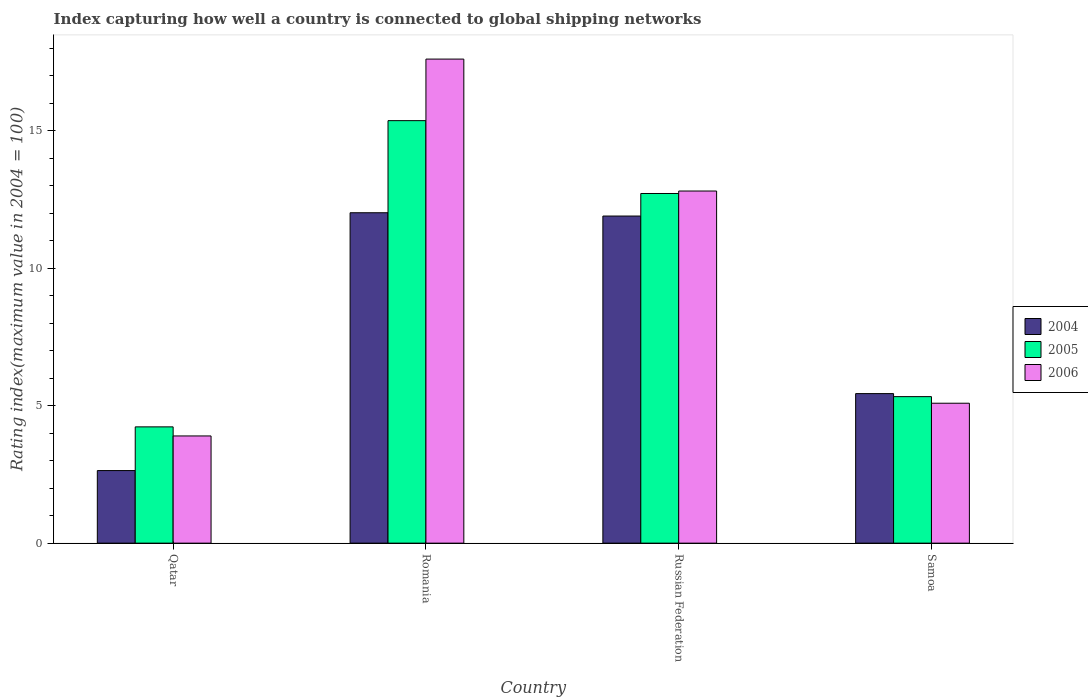How many groups of bars are there?
Your response must be concise. 4. Are the number of bars per tick equal to the number of legend labels?
Ensure brevity in your answer.  Yes. Are the number of bars on each tick of the X-axis equal?
Your answer should be compact. Yes. How many bars are there on the 2nd tick from the right?
Make the answer very short. 3. What is the label of the 2nd group of bars from the left?
Keep it short and to the point. Romania. In how many cases, is the number of bars for a given country not equal to the number of legend labels?
Provide a short and direct response. 0. What is the rating index in 2006 in Qatar?
Provide a succinct answer. 3.9. Across all countries, what is the maximum rating index in 2004?
Ensure brevity in your answer.  12.02. Across all countries, what is the minimum rating index in 2005?
Offer a terse response. 4.23. In which country was the rating index in 2004 maximum?
Make the answer very short. Romania. In which country was the rating index in 2006 minimum?
Your answer should be compact. Qatar. What is the total rating index in 2004 in the graph?
Ensure brevity in your answer.  32. What is the difference between the rating index in 2005 in Qatar and that in Romania?
Your answer should be very brief. -11.14. What is the difference between the rating index in 2006 in Qatar and the rating index in 2005 in Romania?
Ensure brevity in your answer.  -11.47. What is the average rating index in 2005 per country?
Offer a very short reply. 9.41. What is the difference between the rating index of/in 2006 and rating index of/in 2005 in Russian Federation?
Your response must be concise. 0.09. In how many countries, is the rating index in 2004 greater than 9?
Your answer should be compact. 2. What is the ratio of the rating index in 2004 in Romania to that in Samoa?
Provide a short and direct response. 2.21. Is the rating index in 2005 in Russian Federation less than that in Samoa?
Keep it short and to the point. No. Is the difference between the rating index in 2006 in Qatar and Romania greater than the difference between the rating index in 2005 in Qatar and Romania?
Your answer should be very brief. No. What is the difference between the highest and the second highest rating index in 2004?
Make the answer very short. -0.12. What is the difference between the highest and the lowest rating index in 2005?
Offer a terse response. 11.14. What does the 2nd bar from the right in Qatar represents?
Your answer should be very brief. 2005. How many bars are there?
Your answer should be compact. 12. Are all the bars in the graph horizontal?
Make the answer very short. No. What is the difference between two consecutive major ticks on the Y-axis?
Provide a short and direct response. 5. Are the values on the major ticks of Y-axis written in scientific E-notation?
Keep it short and to the point. No. Does the graph contain any zero values?
Provide a succinct answer. No. Does the graph contain grids?
Your response must be concise. No. How are the legend labels stacked?
Make the answer very short. Vertical. What is the title of the graph?
Provide a short and direct response. Index capturing how well a country is connected to global shipping networks. What is the label or title of the Y-axis?
Provide a succinct answer. Rating index(maximum value in 2004 = 100). What is the Rating index(maximum value in 2004 = 100) in 2004 in Qatar?
Your answer should be very brief. 2.64. What is the Rating index(maximum value in 2004 = 100) of 2005 in Qatar?
Give a very brief answer. 4.23. What is the Rating index(maximum value in 2004 = 100) of 2006 in Qatar?
Give a very brief answer. 3.9. What is the Rating index(maximum value in 2004 = 100) in 2004 in Romania?
Offer a very short reply. 12.02. What is the Rating index(maximum value in 2004 = 100) of 2005 in Romania?
Provide a succinct answer. 15.37. What is the Rating index(maximum value in 2004 = 100) of 2006 in Romania?
Give a very brief answer. 17.61. What is the Rating index(maximum value in 2004 = 100) of 2005 in Russian Federation?
Provide a succinct answer. 12.72. What is the Rating index(maximum value in 2004 = 100) of 2006 in Russian Federation?
Offer a terse response. 12.81. What is the Rating index(maximum value in 2004 = 100) of 2004 in Samoa?
Your answer should be very brief. 5.44. What is the Rating index(maximum value in 2004 = 100) in 2005 in Samoa?
Provide a succinct answer. 5.33. What is the Rating index(maximum value in 2004 = 100) of 2006 in Samoa?
Provide a succinct answer. 5.09. Across all countries, what is the maximum Rating index(maximum value in 2004 = 100) in 2004?
Ensure brevity in your answer.  12.02. Across all countries, what is the maximum Rating index(maximum value in 2004 = 100) of 2005?
Provide a short and direct response. 15.37. Across all countries, what is the maximum Rating index(maximum value in 2004 = 100) of 2006?
Keep it short and to the point. 17.61. Across all countries, what is the minimum Rating index(maximum value in 2004 = 100) in 2004?
Ensure brevity in your answer.  2.64. Across all countries, what is the minimum Rating index(maximum value in 2004 = 100) of 2005?
Provide a short and direct response. 4.23. Across all countries, what is the minimum Rating index(maximum value in 2004 = 100) in 2006?
Offer a terse response. 3.9. What is the total Rating index(maximum value in 2004 = 100) in 2004 in the graph?
Keep it short and to the point. 32. What is the total Rating index(maximum value in 2004 = 100) of 2005 in the graph?
Your answer should be compact. 37.65. What is the total Rating index(maximum value in 2004 = 100) in 2006 in the graph?
Provide a succinct answer. 39.41. What is the difference between the Rating index(maximum value in 2004 = 100) of 2004 in Qatar and that in Romania?
Keep it short and to the point. -9.38. What is the difference between the Rating index(maximum value in 2004 = 100) of 2005 in Qatar and that in Romania?
Give a very brief answer. -11.14. What is the difference between the Rating index(maximum value in 2004 = 100) in 2006 in Qatar and that in Romania?
Offer a very short reply. -13.71. What is the difference between the Rating index(maximum value in 2004 = 100) of 2004 in Qatar and that in Russian Federation?
Keep it short and to the point. -9.26. What is the difference between the Rating index(maximum value in 2004 = 100) of 2005 in Qatar and that in Russian Federation?
Your answer should be compact. -8.49. What is the difference between the Rating index(maximum value in 2004 = 100) in 2006 in Qatar and that in Russian Federation?
Make the answer very short. -8.91. What is the difference between the Rating index(maximum value in 2004 = 100) of 2005 in Qatar and that in Samoa?
Offer a very short reply. -1.1. What is the difference between the Rating index(maximum value in 2004 = 100) in 2006 in Qatar and that in Samoa?
Ensure brevity in your answer.  -1.19. What is the difference between the Rating index(maximum value in 2004 = 100) of 2004 in Romania and that in Russian Federation?
Offer a very short reply. 0.12. What is the difference between the Rating index(maximum value in 2004 = 100) of 2005 in Romania and that in Russian Federation?
Give a very brief answer. 2.65. What is the difference between the Rating index(maximum value in 2004 = 100) in 2004 in Romania and that in Samoa?
Provide a short and direct response. 6.58. What is the difference between the Rating index(maximum value in 2004 = 100) of 2005 in Romania and that in Samoa?
Your answer should be compact. 10.04. What is the difference between the Rating index(maximum value in 2004 = 100) in 2006 in Romania and that in Samoa?
Provide a succinct answer. 12.52. What is the difference between the Rating index(maximum value in 2004 = 100) of 2004 in Russian Federation and that in Samoa?
Your answer should be compact. 6.46. What is the difference between the Rating index(maximum value in 2004 = 100) of 2005 in Russian Federation and that in Samoa?
Ensure brevity in your answer.  7.39. What is the difference between the Rating index(maximum value in 2004 = 100) in 2006 in Russian Federation and that in Samoa?
Give a very brief answer. 7.72. What is the difference between the Rating index(maximum value in 2004 = 100) of 2004 in Qatar and the Rating index(maximum value in 2004 = 100) of 2005 in Romania?
Keep it short and to the point. -12.73. What is the difference between the Rating index(maximum value in 2004 = 100) in 2004 in Qatar and the Rating index(maximum value in 2004 = 100) in 2006 in Romania?
Offer a terse response. -14.97. What is the difference between the Rating index(maximum value in 2004 = 100) of 2005 in Qatar and the Rating index(maximum value in 2004 = 100) of 2006 in Romania?
Provide a succinct answer. -13.38. What is the difference between the Rating index(maximum value in 2004 = 100) in 2004 in Qatar and the Rating index(maximum value in 2004 = 100) in 2005 in Russian Federation?
Offer a very short reply. -10.08. What is the difference between the Rating index(maximum value in 2004 = 100) in 2004 in Qatar and the Rating index(maximum value in 2004 = 100) in 2006 in Russian Federation?
Give a very brief answer. -10.17. What is the difference between the Rating index(maximum value in 2004 = 100) of 2005 in Qatar and the Rating index(maximum value in 2004 = 100) of 2006 in Russian Federation?
Ensure brevity in your answer.  -8.58. What is the difference between the Rating index(maximum value in 2004 = 100) of 2004 in Qatar and the Rating index(maximum value in 2004 = 100) of 2005 in Samoa?
Make the answer very short. -2.69. What is the difference between the Rating index(maximum value in 2004 = 100) in 2004 in Qatar and the Rating index(maximum value in 2004 = 100) in 2006 in Samoa?
Provide a succinct answer. -2.45. What is the difference between the Rating index(maximum value in 2004 = 100) in 2005 in Qatar and the Rating index(maximum value in 2004 = 100) in 2006 in Samoa?
Keep it short and to the point. -0.86. What is the difference between the Rating index(maximum value in 2004 = 100) of 2004 in Romania and the Rating index(maximum value in 2004 = 100) of 2006 in Russian Federation?
Offer a very short reply. -0.79. What is the difference between the Rating index(maximum value in 2004 = 100) in 2005 in Romania and the Rating index(maximum value in 2004 = 100) in 2006 in Russian Federation?
Offer a very short reply. 2.56. What is the difference between the Rating index(maximum value in 2004 = 100) of 2004 in Romania and the Rating index(maximum value in 2004 = 100) of 2005 in Samoa?
Ensure brevity in your answer.  6.69. What is the difference between the Rating index(maximum value in 2004 = 100) of 2004 in Romania and the Rating index(maximum value in 2004 = 100) of 2006 in Samoa?
Provide a short and direct response. 6.93. What is the difference between the Rating index(maximum value in 2004 = 100) of 2005 in Romania and the Rating index(maximum value in 2004 = 100) of 2006 in Samoa?
Keep it short and to the point. 10.28. What is the difference between the Rating index(maximum value in 2004 = 100) of 2004 in Russian Federation and the Rating index(maximum value in 2004 = 100) of 2005 in Samoa?
Ensure brevity in your answer.  6.57. What is the difference between the Rating index(maximum value in 2004 = 100) of 2004 in Russian Federation and the Rating index(maximum value in 2004 = 100) of 2006 in Samoa?
Provide a short and direct response. 6.81. What is the difference between the Rating index(maximum value in 2004 = 100) in 2005 in Russian Federation and the Rating index(maximum value in 2004 = 100) in 2006 in Samoa?
Your answer should be very brief. 7.63. What is the average Rating index(maximum value in 2004 = 100) in 2005 per country?
Provide a succinct answer. 9.41. What is the average Rating index(maximum value in 2004 = 100) in 2006 per country?
Offer a terse response. 9.85. What is the difference between the Rating index(maximum value in 2004 = 100) of 2004 and Rating index(maximum value in 2004 = 100) of 2005 in Qatar?
Provide a short and direct response. -1.59. What is the difference between the Rating index(maximum value in 2004 = 100) in 2004 and Rating index(maximum value in 2004 = 100) in 2006 in Qatar?
Provide a short and direct response. -1.26. What is the difference between the Rating index(maximum value in 2004 = 100) in 2005 and Rating index(maximum value in 2004 = 100) in 2006 in Qatar?
Make the answer very short. 0.33. What is the difference between the Rating index(maximum value in 2004 = 100) of 2004 and Rating index(maximum value in 2004 = 100) of 2005 in Romania?
Your answer should be compact. -3.35. What is the difference between the Rating index(maximum value in 2004 = 100) in 2004 and Rating index(maximum value in 2004 = 100) in 2006 in Romania?
Give a very brief answer. -5.59. What is the difference between the Rating index(maximum value in 2004 = 100) of 2005 and Rating index(maximum value in 2004 = 100) of 2006 in Romania?
Your answer should be very brief. -2.24. What is the difference between the Rating index(maximum value in 2004 = 100) of 2004 and Rating index(maximum value in 2004 = 100) of 2005 in Russian Federation?
Give a very brief answer. -0.82. What is the difference between the Rating index(maximum value in 2004 = 100) of 2004 and Rating index(maximum value in 2004 = 100) of 2006 in Russian Federation?
Ensure brevity in your answer.  -0.91. What is the difference between the Rating index(maximum value in 2004 = 100) in 2005 and Rating index(maximum value in 2004 = 100) in 2006 in Russian Federation?
Offer a terse response. -0.09. What is the difference between the Rating index(maximum value in 2004 = 100) in 2004 and Rating index(maximum value in 2004 = 100) in 2005 in Samoa?
Your answer should be compact. 0.11. What is the difference between the Rating index(maximum value in 2004 = 100) in 2005 and Rating index(maximum value in 2004 = 100) in 2006 in Samoa?
Make the answer very short. 0.24. What is the ratio of the Rating index(maximum value in 2004 = 100) of 2004 in Qatar to that in Romania?
Your response must be concise. 0.22. What is the ratio of the Rating index(maximum value in 2004 = 100) in 2005 in Qatar to that in Romania?
Make the answer very short. 0.28. What is the ratio of the Rating index(maximum value in 2004 = 100) in 2006 in Qatar to that in Romania?
Keep it short and to the point. 0.22. What is the ratio of the Rating index(maximum value in 2004 = 100) of 2004 in Qatar to that in Russian Federation?
Provide a succinct answer. 0.22. What is the ratio of the Rating index(maximum value in 2004 = 100) of 2005 in Qatar to that in Russian Federation?
Keep it short and to the point. 0.33. What is the ratio of the Rating index(maximum value in 2004 = 100) of 2006 in Qatar to that in Russian Federation?
Your response must be concise. 0.3. What is the ratio of the Rating index(maximum value in 2004 = 100) of 2004 in Qatar to that in Samoa?
Ensure brevity in your answer.  0.49. What is the ratio of the Rating index(maximum value in 2004 = 100) of 2005 in Qatar to that in Samoa?
Your answer should be compact. 0.79. What is the ratio of the Rating index(maximum value in 2004 = 100) in 2006 in Qatar to that in Samoa?
Your answer should be very brief. 0.77. What is the ratio of the Rating index(maximum value in 2004 = 100) in 2004 in Romania to that in Russian Federation?
Provide a succinct answer. 1.01. What is the ratio of the Rating index(maximum value in 2004 = 100) in 2005 in Romania to that in Russian Federation?
Provide a short and direct response. 1.21. What is the ratio of the Rating index(maximum value in 2004 = 100) of 2006 in Romania to that in Russian Federation?
Provide a short and direct response. 1.37. What is the ratio of the Rating index(maximum value in 2004 = 100) in 2004 in Romania to that in Samoa?
Give a very brief answer. 2.21. What is the ratio of the Rating index(maximum value in 2004 = 100) of 2005 in Romania to that in Samoa?
Offer a terse response. 2.88. What is the ratio of the Rating index(maximum value in 2004 = 100) of 2006 in Romania to that in Samoa?
Your response must be concise. 3.46. What is the ratio of the Rating index(maximum value in 2004 = 100) in 2004 in Russian Federation to that in Samoa?
Give a very brief answer. 2.19. What is the ratio of the Rating index(maximum value in 2004 = 100) in 2005 in Russian Federation to that in Samoa?
Give a very brief answer. 2.39. What is the ratio of the Rating index(maximum value in 2004 = 100) of 2006 in Russian Federation to that in Samoa?
Keep it short and to the point. 2.52. What is the difference between the highest and the second highest Rating index(maximum value in 2004 = 100) of 2004?
Your response must be concise. 0.12. What is the difference between the highest and the second highest Rating index(maximum value in 2004 = 100) in 2005?
Ensure brevity in your answer.  2.65. What is the difference between the highest and the lowest Rating index(maximum value in 2004 = 100) of 2004?
Provide a short and direct response. 9.38. What is the difference between the highest and the lowest Rating index(maximum value in 2004 = 100) of 2005?
Your response must be concise. 11.14. What is the difference between the highest and the lowest Rating index(maximum value in 2004 = 100) of 2006?
Keep it short and to the point. 13.71. 